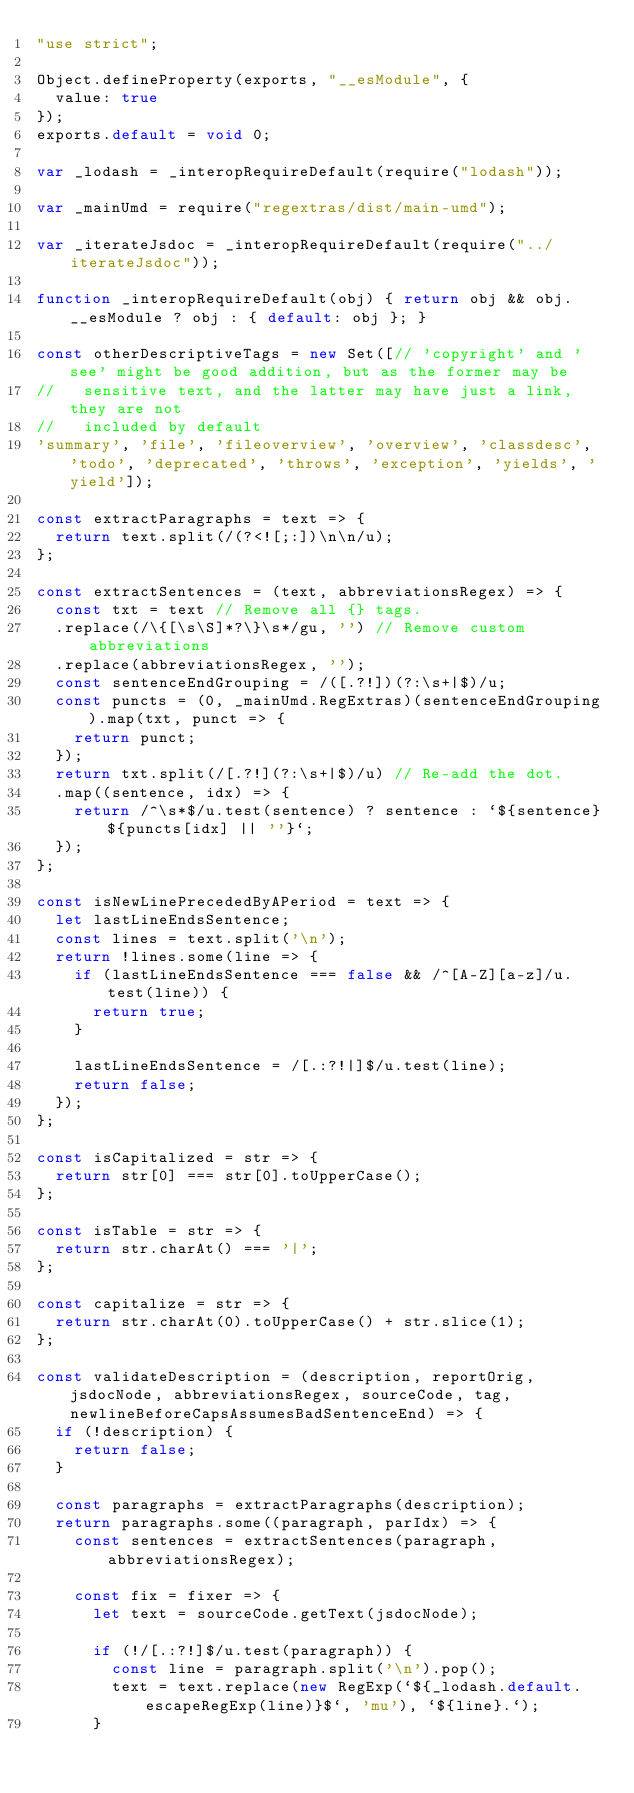Convert code to text. <code><loc_0><loc_0><loc_500><loc_500><_JavaScript_>"use strict";

Object.defineProperty(exports, "__esModule", {
  value: true
});
exports.default = void 0;

var _lodash = _interopRequireDefault(require("lodash"));

var _mainUmd = require("regextras/dist/main-umd");

var _iterateJsdoc = _interopRequireDefault(require("../iterateJsdoc"));

function _interopRequireDefault(obj) { return obj && obj.__esModule ? obj : { default: obj }; }

const otherDescriptiveTags = new Set([// 'copyright' and 'see' might be good addition, but as the former may be
//   sensitive text, and the latter may have just a link, they are not
//   included by default
'summary', 'file', 'fileoverview', 'overview', 'classdesc', 'todo', 'deprecated', 'throws', 'exception', 'yields', 'yield']);

const extractParagraphs = text => {
  return text.split(/(?<![;:])\n\n/u);
};

const extractSentences = (text, abbreviationsRegex) => {
  const txt = text // Remove all {} tags.
  .replace(/\{[\s\S]*?\}\s*/gu, '') // Remove custom abbreviations
  .replace(abbreviationsRegex, '');
  const sentenceEndGrouping = /([.?!])(?:\s+|$)/u;
  const puncts = (0, _mainUmd.RegExtras)(sentenceEndGrouping).map(txt, punct => {
    return punct;
  });
  return txt.split(/[.?!](?:\s+|$)/u) // Re-add the dot.
  .map((sentence, idx) => {
    return /^\s*$/u.test(sentence) ? sentence : `${sentence}${puncts[idx] || ''}`;
  });
};

const isNewLinePrecededByAPeriod = text => {
  let lastLineEndsSentence;
  const lines = text.split('\n');
  return !lines.some(line => {
    if (lastLineEndsSentence === false && /^[A-Z][a-z]/u.test(line)) {
      return true;
    }

    lastLineEndsSentence = /[.:?!|]$/u.test(line);
    return false;
  });
};

const isCapitalized = str => {
  return str[0] === str[0].toUpperCase();
};

const isTable = str => {
  return str.charAt() === '|';
};

const capitalize = str => {
  return str.charAt(0).toUpperCase() + str.slice(1);
};

const validateDescription = (description, reportOrig, jsdocNode, abbreviationsRegex, sourceCode, tag, newlineBeforeCapsAssumesBadSentenceEnd) => {
  if (!description) {
    return false;
  }

  const paragraphs = extractParagraphs(description);
  return paragraphs.some((paragraph, parIdx) => {
    const sentences = extractSentences(paragraph, abbreviationsRegex);

    const fix = fixer => {
      let text = sourceCode.getText(jsdocNode);

      if (!/[.:?!]$/u.test(paragraph)) {
        const line = paragraph.split('\n').pop();
        text = text.replace(new RegExp(`${_lodash.default.escapeRegExp(line)}$`, 'mu'), `${line}.`);
      }
</code> 